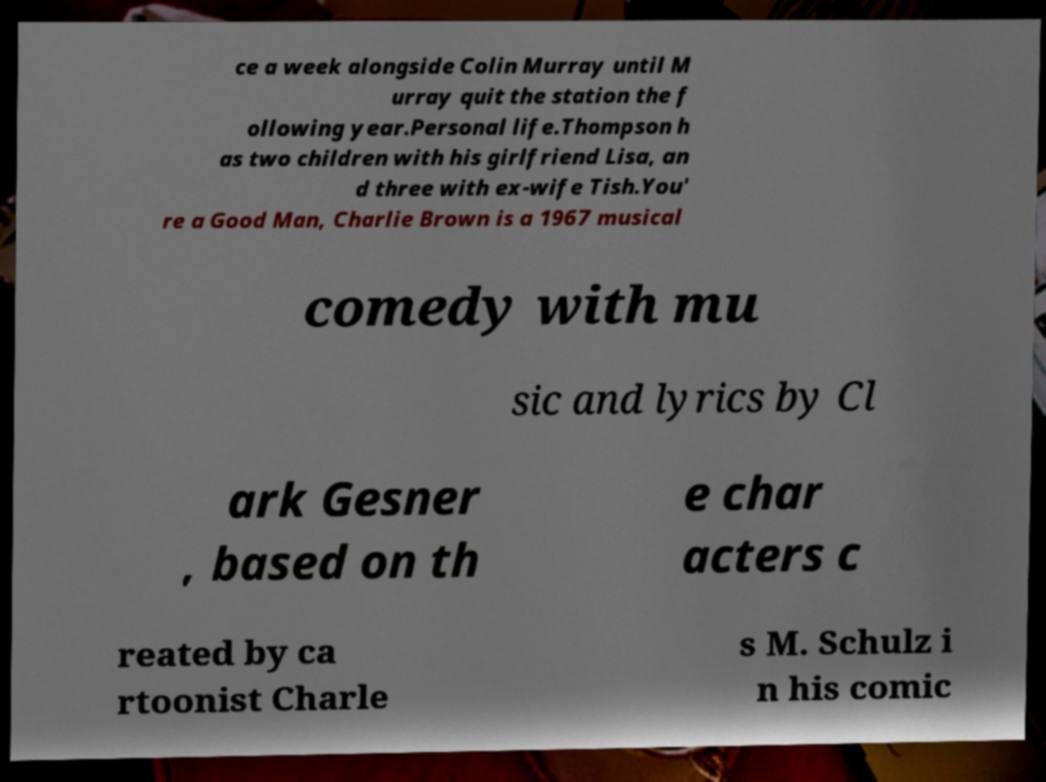For documentation purposes, I need the text within this image transcribed. Could you provide that? ce a week alongside Colin Murray until M urray quit the station the f ollowing year.Personal life.Thompson h as two children with his girlfriend Lisa, an d three with ex-wife Tish.You' re a Good Man, Charlie Brown is a 1967 musical comedy with mu sic and lyrics by Cl ark Gesner , based on th e char acters c reated by ca rtoonist Charle s M. Schulz i n his comic 